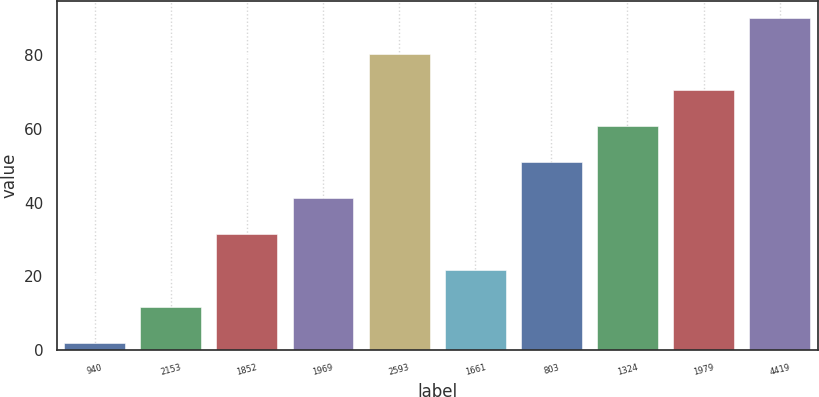<chart> <loc_0><loc_0><loc_500><loc_500><bar_chart><fcel>940<fcel>2153<fcel>1852<fcel>1969<fcel>2593<fcel>1661<fcel>803<fcel>1324<fcel>1979<fcel>4419<nl><fcel>2<fcel>11.8<fcel>31.4<fcel>41.2<fcel>80.4<fcel>21.6<fcel>51<fcel>60.8<fcel>70.6<fcel>90.2<nl></chart> 